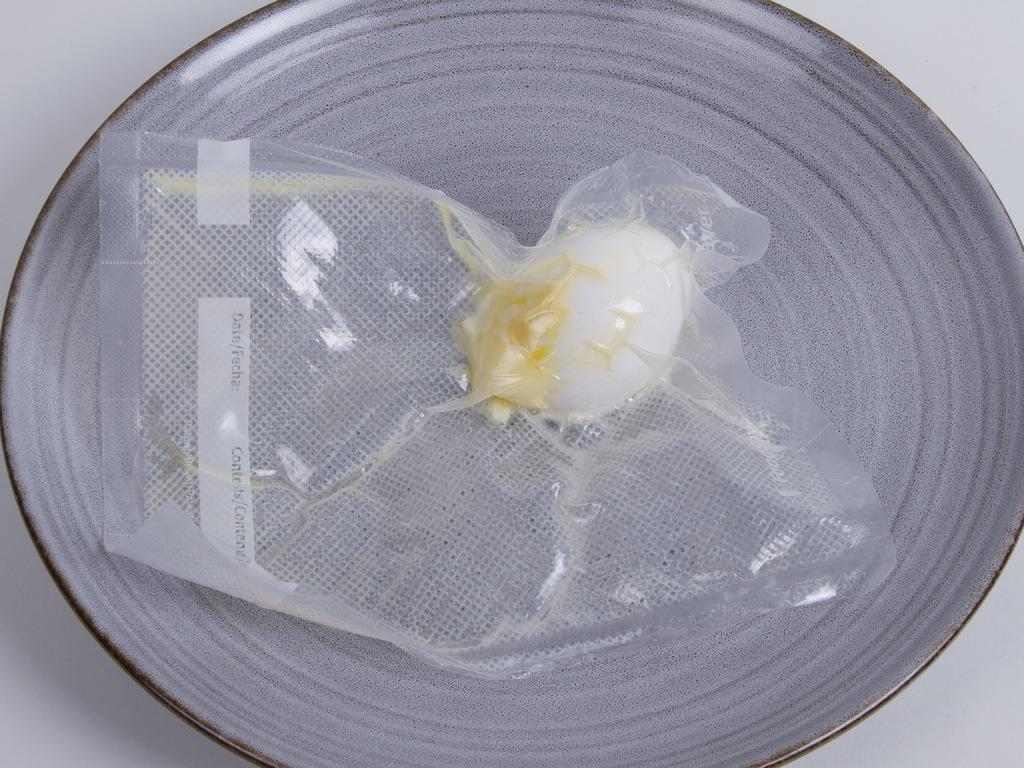What is in the bowl that is visible in the image? There is an egg inside the cover in the bowl. What is the color of the background in the image? The background of the image is white. Can you see any veins on the egg in the image? There is no indication of veins on the egg in the image, as it is not a living organism. What type of mouth is visible in the image? There is no mouth present in the image. 